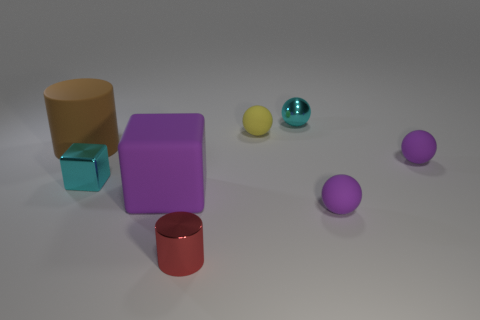Subtract all yellow balls. How many balls are left? 3 Subtract 1 balls. How many balls are left? 3 Add 1 balls. How many objects exist? 9 Subtract all blue balls. Subtract all gray cubes. How many balls are left? 4 Subtract all cylinders. How many objects are left? 6 Add 6 big purple rubber cubes. How many big purple rubber cubes are left? 7 Add 7 tiny red metal objects. How many tiny red metal objects exist? 8 Subtract 0 blue cylinders. How many objects are left? 8 Subtract all big yellow metallic things. Subtract all cubes. How many objects are left? 6 